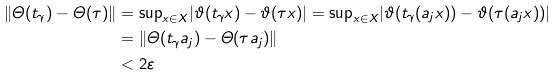<formula> <loc_0><loc_0><loc_500><loc_500>\| \varTheta ( t _ { \gamma } ) - \varTheta ( \tau ) \| & = { \sup } _ { x \in X } | \vartheta ( t _ { \gamma } x ) - \vartheta ( \tau x ) | = { \sup } _ { x \in X } | \vartheta ( t _ { \gamma } ( a _ { j } x ) ) - \vartheta ( \tau ( a _ { j } x ) ) | \\ & = \| \varTheta ( t _ { \gamma } a _ { j } ) - \varTheta ( \tau a _ { j } ) \| \\ & < 2 \varepsilon</formula> 